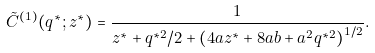Convert formula to latex. <formula><loc_0><loc_0><loc_500><loc_500>\tilde { C } ^ { ( 1 ) } ( q ^ { * } ; z ^ { * } ) = \frac { 1 } { z ^ { * } + q ^ { * 2 } / 2 + \left ( 4 a z ^ { * } + 8 a b + a ^ { 2 } q ^ { * 2 } \right ) ^ { 1 / 2 } } .</formula> 